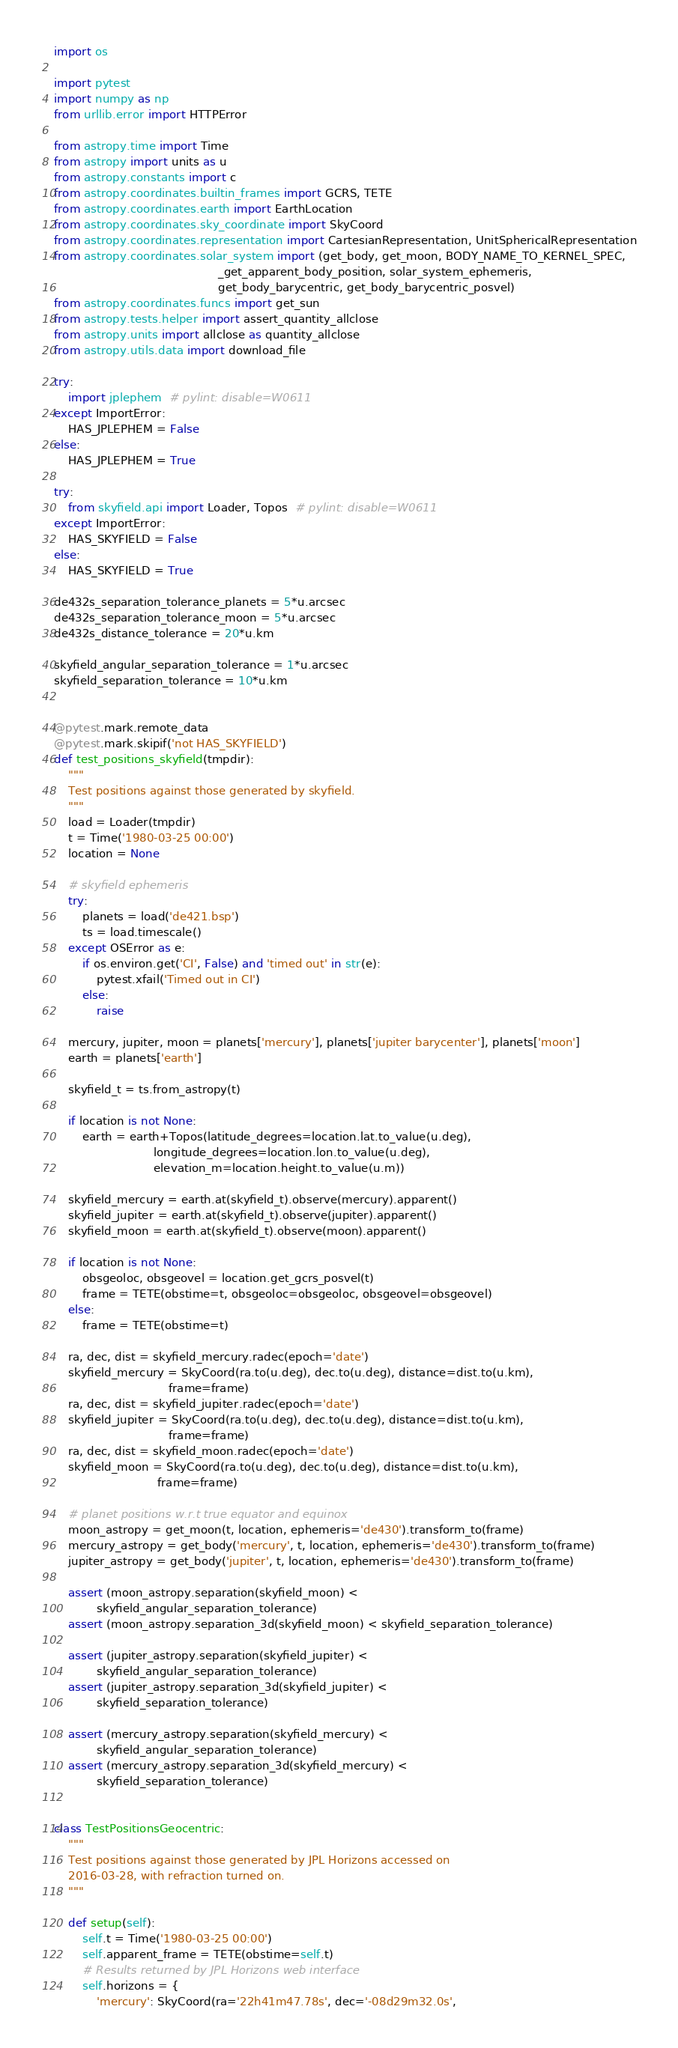<code> <loc_0><loc_0><loc_500><loc_500><_Python_>import os

import pytest
import numpy as np
from urllib.error import HTTPError

from astropy.time import Time
from astropy import units as u
from astropy.constants import c
from astropy.coordinates.builtin_frames import GCRS, TETE
from astropy.coordinates.earth import EarthLocation
from astropy.coordinates.sky_coordinate import SkyCoord
from astropy.coordinates.representation import CartesianRepresentation, UnitSphericalRepresentation
from astropy.coordinates.solar_system import (get_body, get_moon, BODY_NAME_TO_KERNEL_SPEC,
                                              _get_apparent_body_position, solar_system_ephemeris,
                                              get_body_barycentric, get_body_barycentric_posvel)
from astropy.coordinates.funcs import get_sun
from astropy.tests.helper import assert_quantity_allclose
from astropy.units import allclose as quantity_allclose
from astropy.utils.data import download_file

try:
    import jplephem  # pylint: disable=W0611
except ImportError:
    HAS_JPLEPHEM = False
else:
    HAS_JPLEPHEM = True

try:
    from skyfield.api import Loader, Topos  # pylint: disable=W0611
except ImportError:
    HAS_SKYFIELD = False
else:
    HAS_SKYFIELD = True

de432s_separation_tolerance_planets = 5*u.arcsec
de432s_separation_tolerance_moon = 5*u.arcsec
de432s_distance_tolerance = 20*u.km

skyfield_angular_separation_tolerance = 1*u.arcsec
skyfield_separation_tolerance = 10*u.km


@pytest.mark.remote_data
@pytest.mark.skipif('not HAS_SKYFIELD')
def test_positions_skyfield(tmpdir):
    """
    Test positions against those generated by skyfield.
    """
    load = Loader(tmpdir)
    t = Time('1980-03-25 00:00')
    location = None

    # skyfield ephemeris
    try:
        planets = load('de421.bsp')
        ts = load.timescale()
    except OSError as e:
        if os.environ.get('CI', False) and 'timed out' in str(e):
            pytest.xfail('Timed out in CI')
        else:
            raise

    mercury, jupiter, moon = planets['mercury'], planets['jupiter barycenter'], planets['moon']
    earth = planets['earth']

    skyfield_t = ts.from_astropy(t)

    if location is not None:
        earth = earth+Topos(latitude_degrees=location.lat.to_value(u.deg),
                            longitude_degrees=location.lon.to_value(u.deg),
                            elevation_m=location.height.to_value(u.m))

    skyfield_mercury = earth.at(skyfield_t).observe(mercury).apparent()
    skyfield_jupiter = earth.at(skyfield_t).observe(jupiter).apparent()
    skyfield_moon = earth.at(skyfield_t).observe(moon).apparent()

    if location is not None:
        obsgeoloc, obsgeovel = location.get_gcrs_posvel(t)
        frame = TETE(obstime=t, obsgeoloc=obsgeoloc, obsgeovel=obsgeovel)
    else:
        frame = TETE(obstime=t)

    ra, dec, dist = skyfield_mercury.radec(epoch='date')
    skyfield_mercury = SkyCoord(ra.to(u.deg), dec.to(u.deg), distance=dist.to(u.km),
                                frame=frame)
    ra, dec, dist = skyfield_jupiter.radec(epoch='date')
    skyfield_jupiter = SkyCoord(ra.to(u.deg), dec.to(u.deg), distance=dist.to(u.km),
                                frame=frame)
    ra, dec, dist = skyfield_moon.radec(epoch='date')
    skyfield_moon = SkyCoord(ra.to(u.deg), dec.to(u.deg), distance=dist.to(u.km),
                             frame=frame)

    # planet positions w.r.t true equator and equinox
    moon_astropy = get_moon(t, location, ephemeris='de430').transform_to(frame)
    mercury_astropy = get_body('mercury', t, location, ephemeris='de430').transform_to(frame)
    jupiter_astropy = get_body('jupiter', t, location, ephemeris='de430').transform_to(frame)

    assert (moon_astropy.separation(skyfield_moon) <
            skyfield_angular_separation_tolerance)
    assert (moon_astropy.separation_3d(skyfield_moon) < skyfield_separation_tolerance)

    assert (jupiter_astropy.separation(skyfield_jupiter) <
            skyfield_angular_separation_tolerance)
    assert (jupiter_astropy.separation_3d(skyfield_jupiter) <
            skyfield_separation_tolerance)

    assert (mercury_astropy.separation(skyfield_mercury) <
            skyfield_angular_separation_tolerance)
    assert (mercury_astropy.separation_3d(skyfield_mercury) <
            skyfield_separation_tolerance)


class TestPositionsGeocentric:
    """
    Test positions against those generated by JPL Horizons accessed on
    2016-03-28, with refraction turned on.
    """

    def setup(self):
        self.t = Time('1980-03-25 00:00')
        self.apparent_frame = TETE(obstime=self.t)
        # Results returned by JPL Horizons web interface
        self.horizons = {
            'mercury': SkyCoord(ra='22h41m47.78s', dec='-08d29m32.0s',</code> 